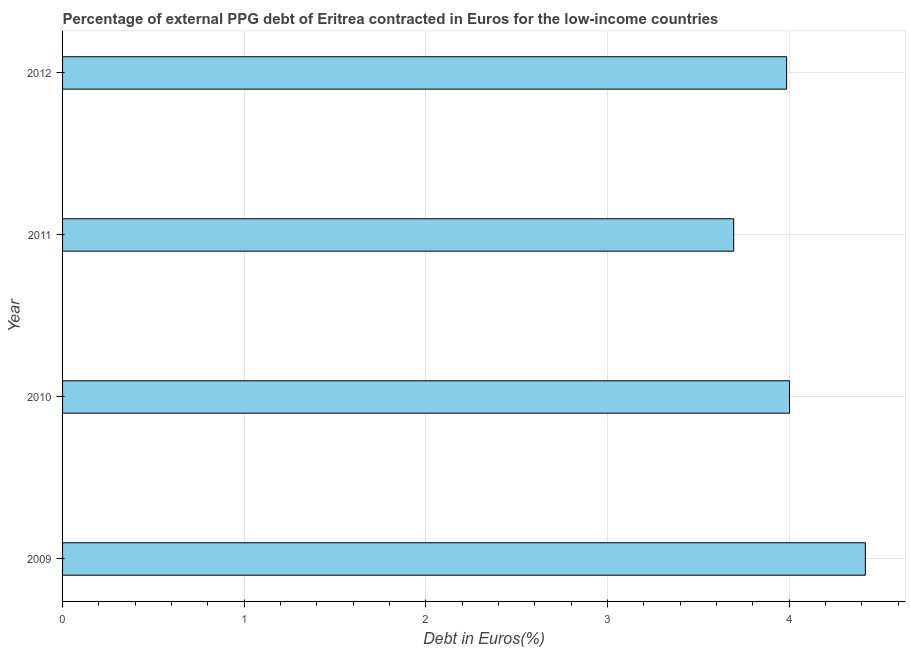Does the graph contain grids?
Offer a very short reply. Yes. What is the title of the graph?
Offer a very short reply. Percentage of external PPG debt of Eritrea contracted in Euros for the low-income countries. What is the label or title of the X-axis?
Your answer should be very brief. Debt in Euros(%). What is the currency composition of ppg debt in 2010?
Provide a succinct answer. 4. Across all years, what is the maximum currency composition of ppg debt?
Provide a short and direct response. 4.42. Across all years, what is the minimum currency composition of ppg debt?
Ensure brevity in your answer.  3.69. In which year was the currency composition of ppg debt maximum?
Offer a very short reply. 2009. In which year was the currency composition of ppg debt minimum?
Offer a terse response. 2011. What is the sum of the currency composition of ppg debt?
Give a very brief answer. 16.1. What is the difference between the currency composition of ppg debt in 2010 and 2011?
Keep it short and to the point. 0.31. What is the average currency composition of ppg debt per year?
Make the answer very short. 4.03. What is the median currency composition of ppg debt?
Your response must be concise. 3.99. What is the ratio of the currency composition of ppg debt in 2009 to that in 2011?
Ensure brevity in your answer.  1.2. Is the currency composition of ppg debt in 2010 less than that in 2011?
Your answer should be compact. No. What is the difference between the highest and the second highest currency composition of ppg debt?
Offer a very short reply. 0.42. Is the sum of the currency composition of ppg debt in 2009 and 2010 greater than the maximum currency composition of ppg debt across all years?
Keep it short and to the point. Yes. What is the difference between the highest and the lowest currency composition of ppg debt?
Provide a succinct answer. 0.72. In how many years, is the currency composition of ppg debt greater than the average currency composition of ppg debt taken over all years?
Provide a succinct answer. 1. How many bars are there?
Your answer should be compact. 4. Are all the bars in the graph horizontal?
Offer a terse response. Yes. What is the Debt in Euros(%) in 2009?
Your response must be concise. 4.42. What is the Debt in Euros(%) of 2010?
Keep it short and to the point. 4. What is the Debt in Euros(%) of 2011?
Provide a short and direct response. 3.69. What is the Debt in Euros(%) in 2012?
Keep it short and to the point. 3.99. What is the difference between the Debt in Euros(%) in 2009 and 2010?
Provide a short and direct response. 0.42. What is the difference between the Debt in Euros(%) in 2009 and 2011?
Your response must be concise. 0.72. What is the difference between the Debt in Euros(%) in 2009 and 2012?
Provide a short and direct response. 0.43. What is the difference between the Debt in Euros(%) in 2010 and 2011?
Ensure brevity in your answer.  0.31. What is the difference between the Debt in Euros(%) in 2010 and 2012?
Keep it short and to the point. 0.02. What is the difference between the Debt in Euros(%) in 2011 and 2012?
Your answer should be very brief. -0.29. What is the ratio of the Debt in Euros(%) in 2009 to that in 2010?
Provide a succinct answer. 1.1. What is the ratio of the Debt in Euros(%) in 2009 to that in 2011?
Keep it short and to the point. 1.2. What is the ratio of the Debt in Euros(%) in 2009 to that in 2012?
Provide a short and direct response. 1.11. What is the ratio of the Debt in Euros(%) in 2010 to that in 2011?
Give a very brief answer. 1.08. What is the ratio of the Debt in Euros(%) in 2010 to that in 2012?
Ensure brevity in your answer.  1. What is the ratio of the Debt in Euros(%) in 2011 to that in 2012?
Your answer should be compact. 0.93. 